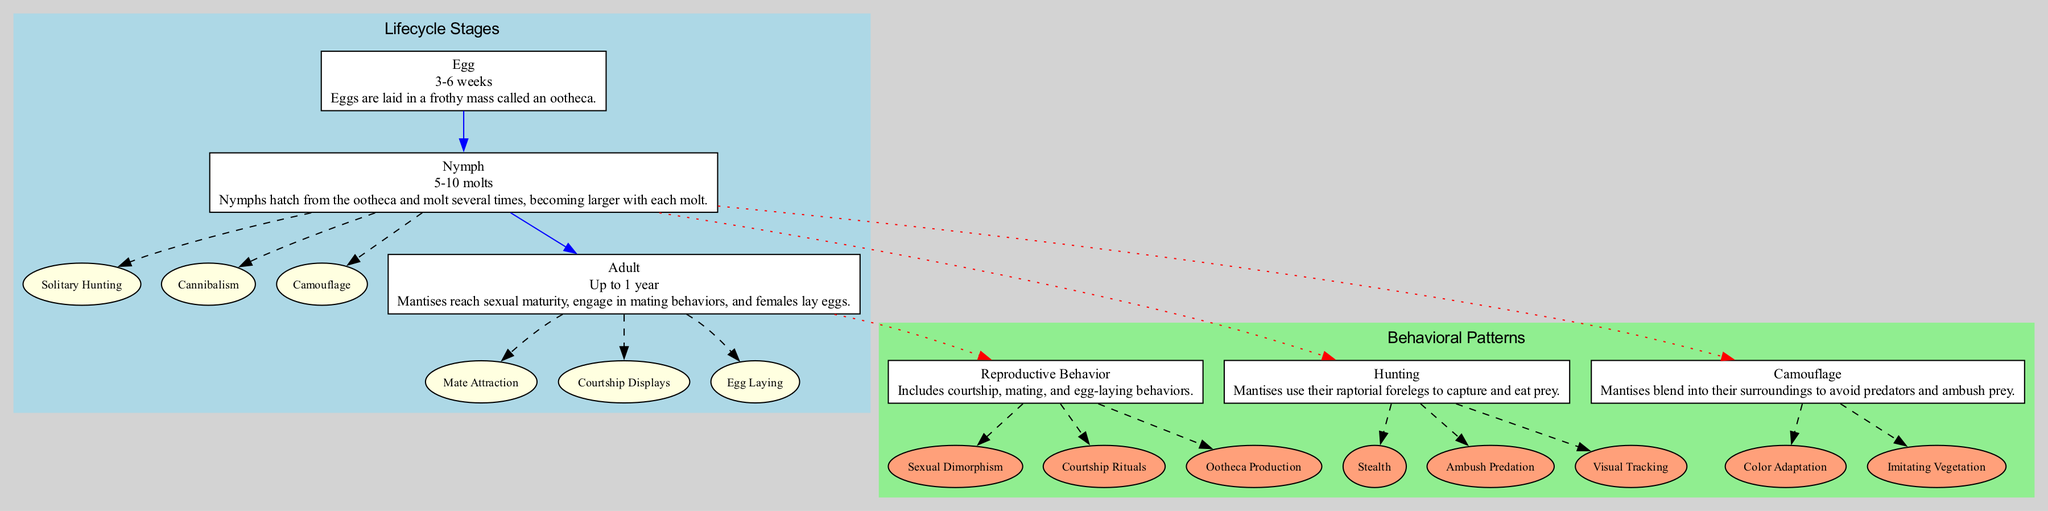What stage lasts up to 1 year? The only lifecycle stage that has a duration of up to 1 year is the Adult stage. This can be identified by looking for the stage description that specifies duration.
Answer: Adult How long do nymphs molt? From the diagram, the Nymph stage indicates that nymphs undergo 5-10 molts during their development. This is sourced directly from the provided lifecycle stages.
Answer: 5-10 molts What is a key behavior of nymphs? The diagram lists several key behaviors associated with the Nymph stage, including Solitary Hunting. This can be found in the specific key behaviors mentioned for nymphs.
Answer: Solitary Hunting Which behavioral pattern includes ootheca production? Reproductive Behavior outlines the production of ootheca as one of its key features. To find this answer, the diagram points to the Reproductive Behavior pattern and its associated key features.
Answer: Reproductive Behavior How many stages are depicted in the lifecycle? There are three lifecycle stages shown: Egg, Nymph, and Adult. Counting the number of distinct stages in the Lifecycle Stages section provides this answer.
Answer: 3 Which stage is connected to Hunting behavior? The Nymph stage is connected to the Hunting behavioral pattern, indicated by the dotted red line connecting the Nymph node to the Hunting node in the diagram.
Answer: Nymph What behavior involves ambush predation? The Hunting behavior is specifically associated with ambush predation, as noted in the key features section under Hunting in the behavioral patterns part of the diagram.
Answer: Hunting What color signifies behavioral patterns in the diagram? The behavioral patterns section of the diagram is filled with light green color, as indicated in the attributes of the subgraph for behavioral patterns.
Answer: Light green What is one key feature of camouflage behavior? One of the key features of Camouflage behavior is Color Adaptation, which can be identified in the key features list for the Camouflage behavioral pattern.
Answer: Color Adaptation 